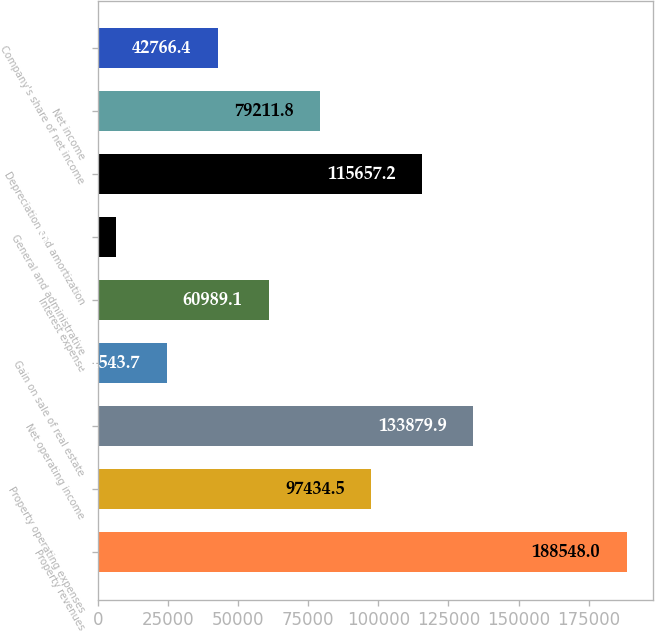Convert chart. <chart><loc_0><loc_0><loc_500><loc_500><bar_chart><fcel>Property revenues<fcel>Property operating expenses<fcel>Net operating income<fcel>Gain on sale of real estate<fcel>Interest expense<fcel>General and administrative<fcel>Depreciation and amortization<fcel>Net income<fcel>Company's share of net income<nl><fcel>188548<fcel>97434.5<fcel>133880<fcel>24543.7<fcel>60989.1<fcel>6321<fcel>115657<fcel>79211.8<fcel>42766.4<nl></chart> 